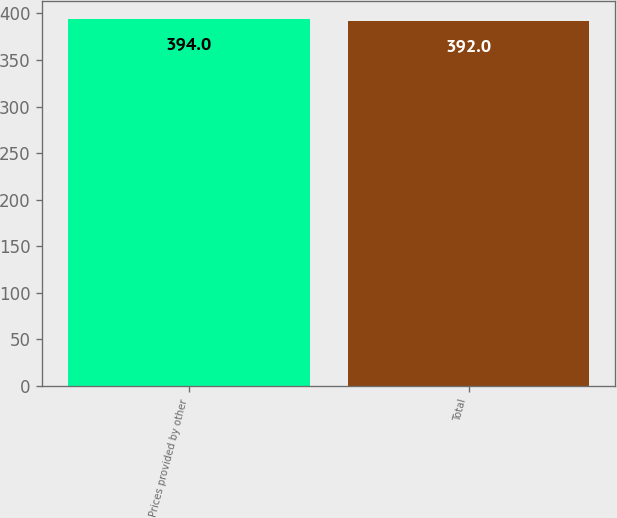Convert chart to OTSL. <chart><loc_0><loc_0><loc_500><loc_500><bar_chart><fcel>Prices provided by other<fcel>Total<nl><fcel>394<fcel>392<nl></chart> 